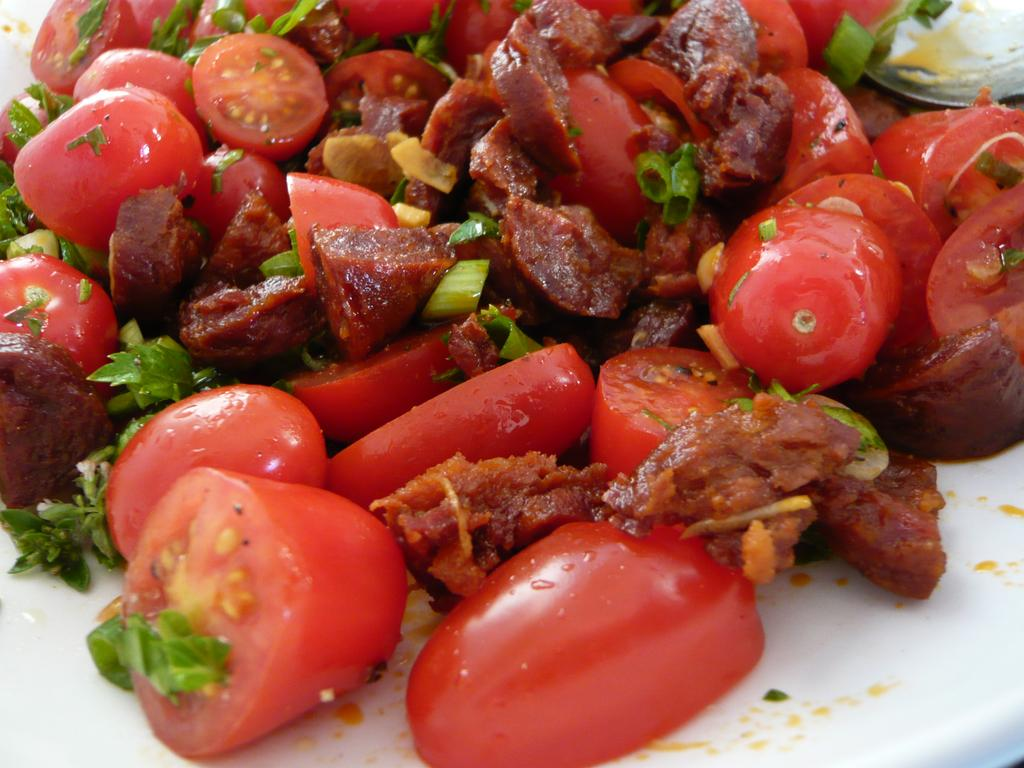What type of items are present in the image? There are food items in the image. Can you describe the surface on which the food items are placed? The food items are on a white color surface. What type of shirt is the food wearing in the image? The food items in the image are not wearing a shirt, as they are inanimate objects and not living beings. 